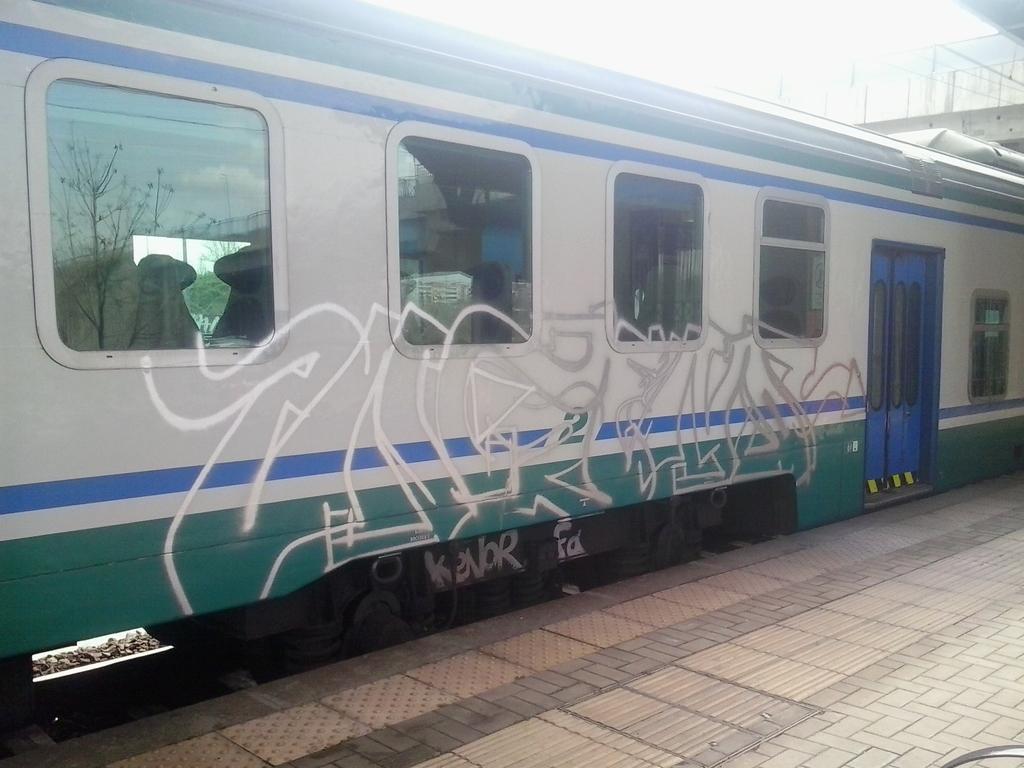Could you give a brief overview of what you see in this image? In this image I can see a train along with the doors and windows. At the bottom of the image there is a platform. On the right top of the image there is a bridge. 